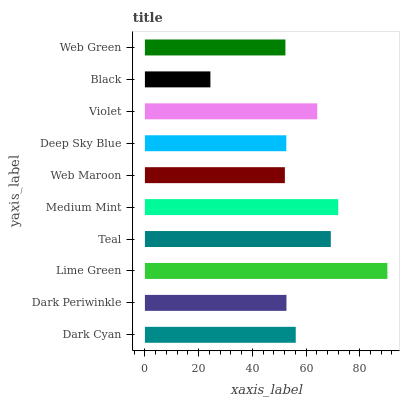Is Black the minimum?
Answer yes or no. Yes. Is Lime Green the maximum?
Answer yes or no. Yes. Is Dark Periwinkle the minimum?
Answer yes or no. No. Is Dark Periwinkle the maximum?
Answer yes or no. No. Is Dark Cyan greater than Dark Periwinkle?
Answer yes or no. Yes. Is Dark Periwinkle less than Dark Cyan?
Answer yes or no. Yes. Is Dark Periwinkle greater than Dark Cyan?
Answer yes or no. No. Is Dark Cyan less than Dark Periwinkle?
Answer yes or no. No. Is Dark Cyan the high median?
Answer yes or no. Yes. Is Dark Periwinkle the low median?
Answer yes or no. Yes. Is Black the high median?
Answer yes or no. No. Is Black the low median?
Answer yes or no. No. 